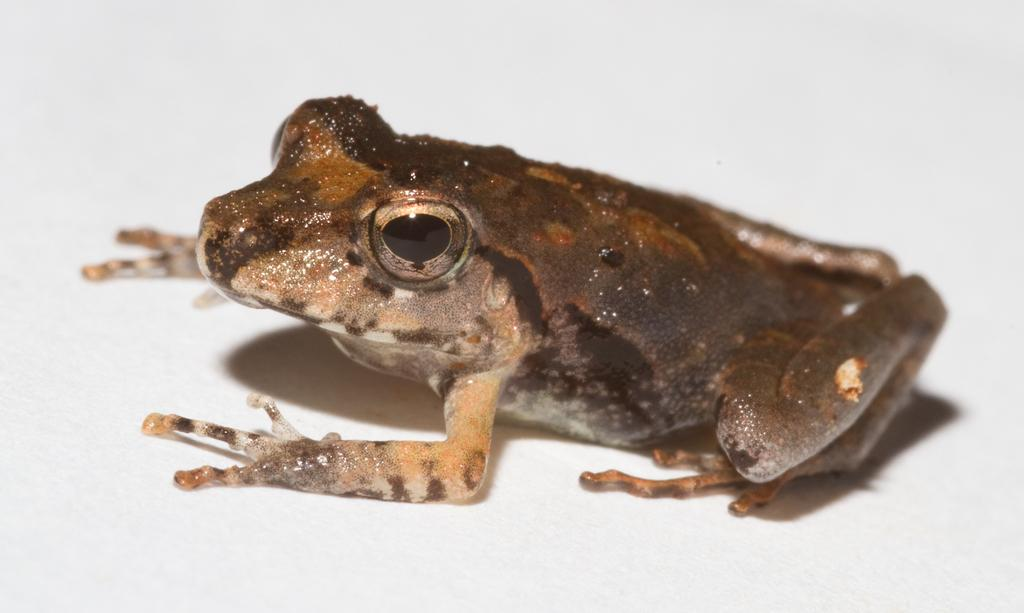What animal is present in the image? There is a frog in the image. What color is the background of the image? The background of the image appears to be white in color. How many babies are present in the image? There are no babies present in the image; it features a frog against a white background. What type of milk can be seen in the image? There is no milk present in the image. 